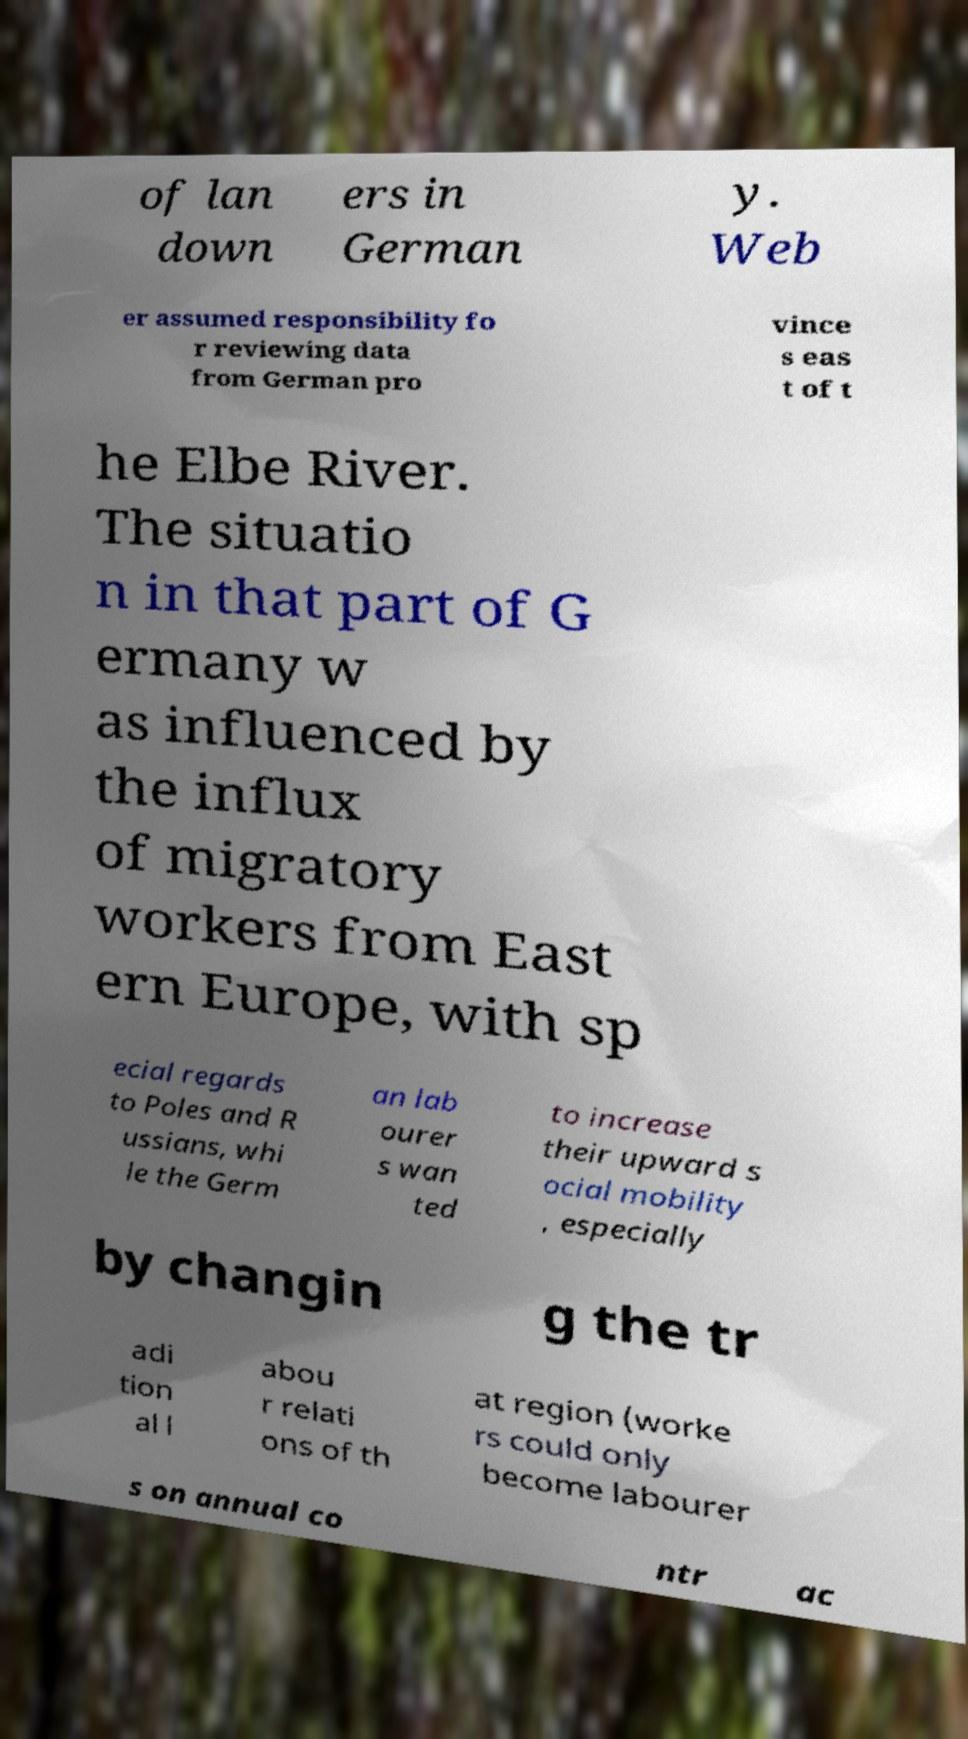What messages or text are displayed in this image? I need them in a readable, typed format. of lan down ers in German y. Web er assumed responsibility fo r reviewing data from German pro vince s eas t of t he Elbe River. The situatio n in that part of G ermany w as influenced by the influx of migratory workers from East ern Europe, with sp ecial regards to Poles and R ussians, whi le the Germ an lab ourer s wan ted to increase their upward s ocial mobility , especially by changin g the tr adi tion al l abou r relati ons of th at region (worke rs could only become labourer s on annual co ntr ac 